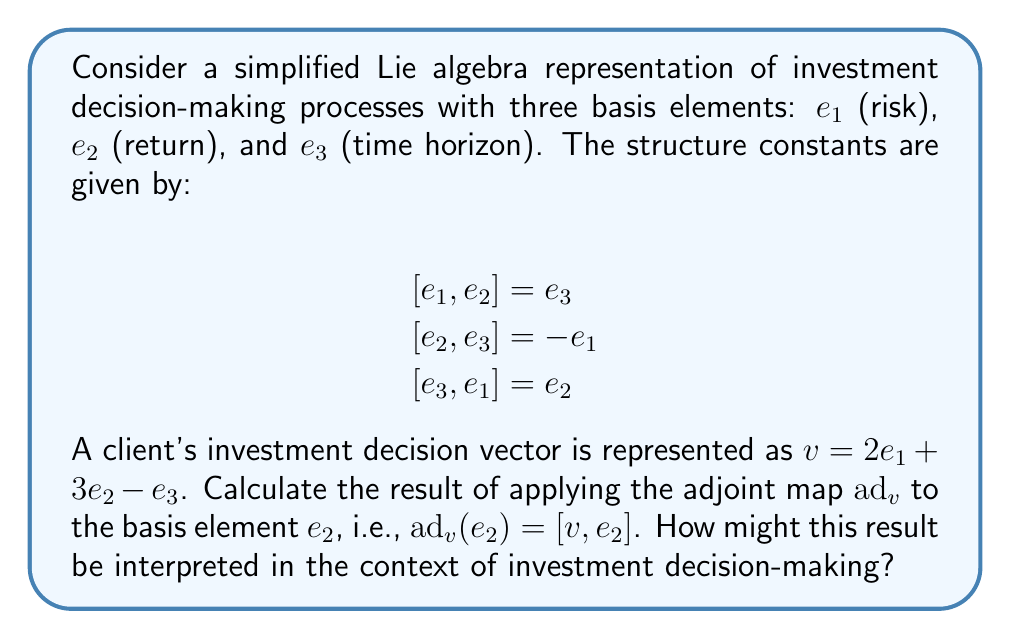Provide a solution to this math problem. To solve this problem, we need to follow these steps:

1) Recall the definition of the adjoint map: $ad_v(x) = [v, x]$

2) Use the given investment decision vector: $v = 2e_1 + 3e_2 - e_3$

3) Calculate $[v, e_2]$ using the linearity of the Lie bracket:

   $[v, e_2] = [2e_1 + 3e_2 - e_3, e_2]$
              $= 2[e_1, e_2] + 3[e_2, e_2] - [e_3, e_2]$

4) Apply the given structure constants and the antisymmetry property of Lie brackets:

   $2[e_1, e_2] = 2e_3$
   $3[e_2, e_2] = 0$ (since $[x,x] = 0$ for any element x in a Lie algebra)
   $-[e_3, e_2] = [e_2, e_3] = -e_1$

5) Sum up the results:

   $ad_v(e_2) = [v, e_2] = 2e_3 + 0 - e_1 = -e_1 + 2e_3$

Interpretation in the context of investment decision-making:

The result $-e_1 + 2e_3$ suggests that the interaction between the client's investment decision (represented by $v$) and the return consideration ($e_2$) leads to:

1. A negative effect on risk ($-e_1$): This could imply that focusing on returns might lead to a reduction in perceived risk.
2. A positive effect on time horizon ($2e_3$): This might indicate that considering returns encourages thinking about longer investment periods.

This analysis could help a financial advisor understand how a client's focus on returns might influence their perception of risk and investment timeline, potentially revealing cognitive biases in their decision-making process.
Answer: $ad_v(e_2) = -e_1 + 2e_3$ 